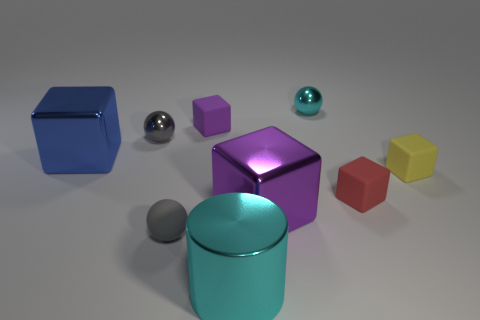Subtract all yellow cubes. How many cubes are left? 4 Subtract all tiny purple rubber blocks. How many blocks are left? 4 Subtract all brown blocks. Subtract all purple balls. How many blocks are left? 5 Add 1 gray matte spheres. How many objects exist? 10 Subtract all spheres. How many objects are left? 6 Add 2 rubber objects. How many rubber objects are left? 6 Add 8 red shiny cubes. How many red shiny cubes exist? 8 Subtract 0 green balls. How many objects are left? 9 Subtract all blue cubes. Subtract all small cyan things. How many objects are left? 7 